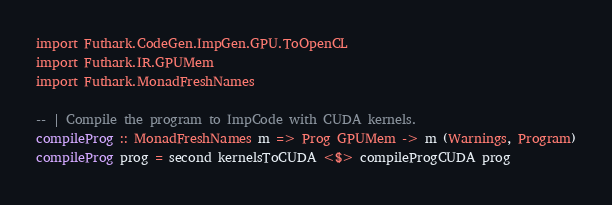Convert code to text. <code><loc_0><loc_0><loc_500><loc_500><_Haskell_>import Futhark.CodeGen.ImpGen.GPU.ToOpenCL
import Futhark.IR.GPUMem
import Futhark.MonadFreshNames

-- | Compile the program to ImpCode with CUDA kernels.
compileProg :: MonadFreshNames m => Prog GPUMem -> m (Warnings, Program)
compileProg prog = second kernelsToCUDA <$> compileProgCUDA prog
</code> 